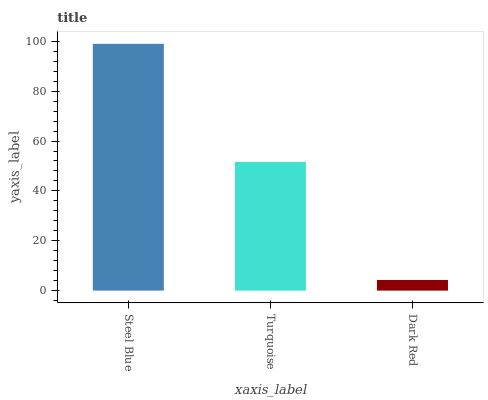Is Dark Red the minimum?
Answer yes or no. Yes. Is Steel Blue the maximum?
Answer yes or no. Yes. Is Turquoise the minimum?
Answer yes or no. No. Is Turquoise the maximum?
Answer yes or no. No. Is Steel Blue greater than Turquoise?
Answer yes or no. Yes. Is Turquoise less than Steel Blue?
Answer yes or no. Yes. Is Turquoise greater than Steel Blue?
Answer yes or no. No. Is Steel Blue less than Turquoise?
Answer yes or no. No. Is Turquoise the high median?
Answer yes or no. Yes. Is Turquoise the low median?
Answer yes or no. Yes. Is Dark Red the high median?
Answer yes or no. No. Is Dark Red the low median?
Answer yes or no. No. 